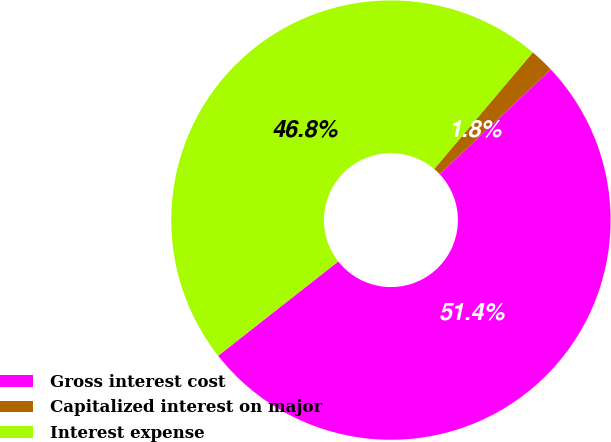<chart> <loc_0><loc_0><loc_500><loc_500><pie_chart><fcel>Gross interest cost<fcel>Capitalized interest on major<fcel>Interest expense<nl><fcel>51.44%<fcel>1.79%<fcel>46.76%<nl></chart> 